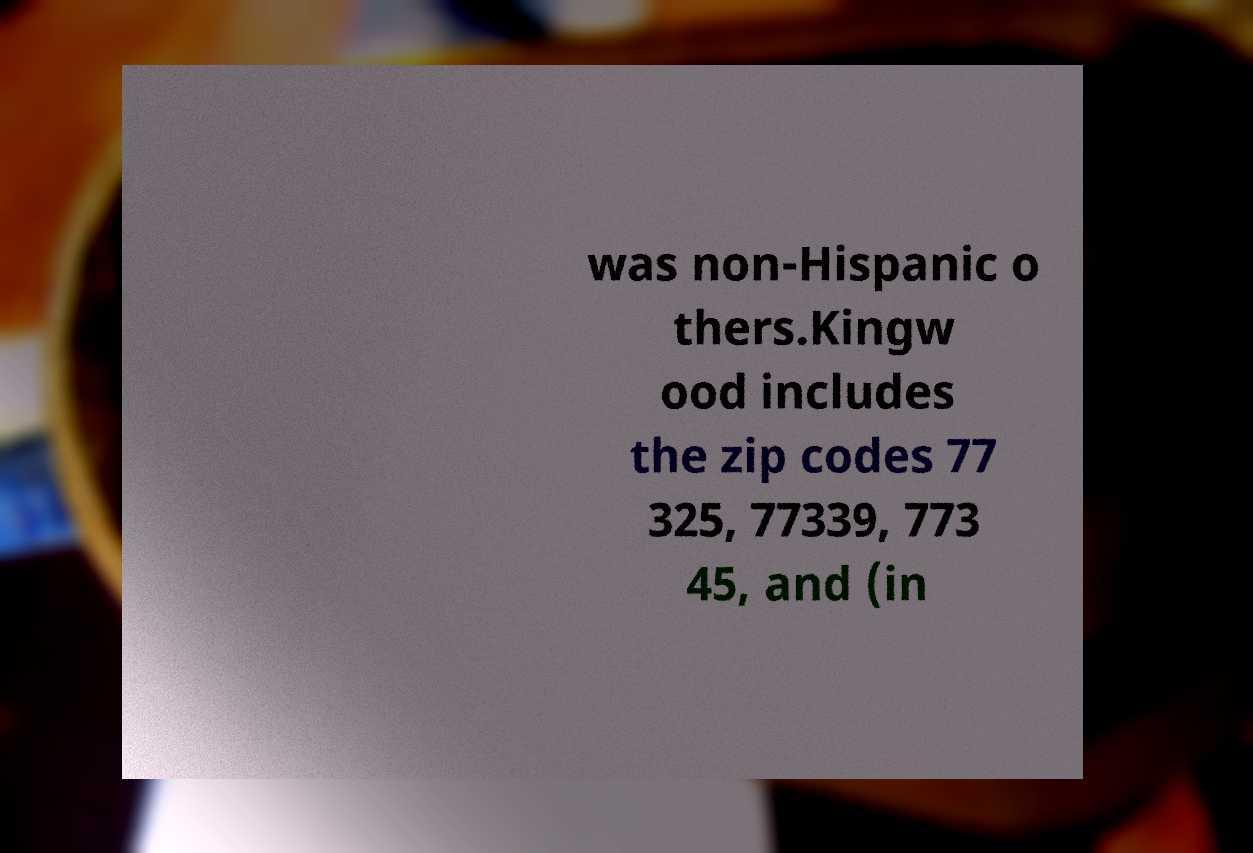I need the written content from this picture converted into text. Can you do that? was non-Hispanic o thers.Kingw ood includes the zip codes 77 325, 77339, 773 45, and (in 